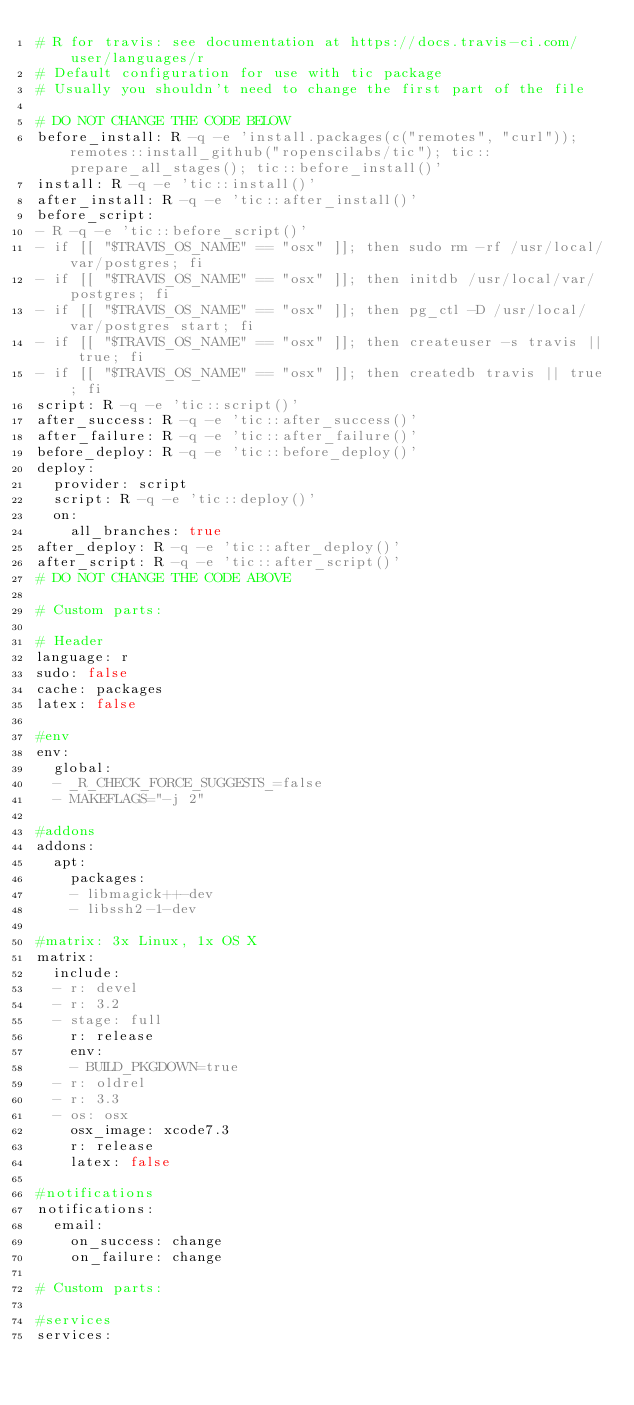Convert code to text. <code><loc_0><loc_0><loc_500><loc_500><_YAML_># R for travis: see documentation at https://docs.travis-ci.com/user/languages/r
# Default configuration for use with tic package
# Usually you shouldn't need to change the first part of the file

# DO NOT CHANGE THE CODE BELOW
before_install: R -q -e 'install.packages(c("remotes", "curl")); remotes::install_github("ropenscilabs/tic"); tic::prepare_all_stages(); tic::before_install()'
install: R -q -e 'tic::install()'
after_install: R -q -e 'tic::after_install()'
before_script:
- R -q -e 'tic::before_script()'
- if [[ "$TRAVIS_OS_NAME" == "osx" ]]; then sudo rm -rf /usr/local/var/postgres; fi
- if [[ "$TRAVIS_OS_NAME" == "osx" ]]; then initdb /usr/local/var/postgres; fi
- if [[ "$TRAVIS_OS_NAME" == "osx" ]]; then pg_ctl -D /usr/local/var/postgres start; fi
- if [[ "$TRAVIS_OS_NAME" == "osx" ]]; then createuser -s travis || true; fi
- if [[ "$TRAVIS_OS_NAME" == "osx" ]]; then createdb travis || true; fi
script: R -q -e 'tic::script()'
after_success: R -q -e 'tic::after_success()'
after_failure: R -q -e 'tic::after_failure()'
before_deploy: R -q -e 'tic::before_deploy()'
deploy:
  provider: script
  script: R -q -e 'tic::deploy()'
  on:
    all_branches: true
after_deploy: R -q -e 'tic::after_deploy()'
after_script: R -q -e 'tic::after_script()'
# DO NOT CHANGE THE CODE ABOVE

# Custom parts:

# Header
language: r
sudo: false
cache: packages
latex: false

#env
env:
  global:
  - _R_CHECK_FORCE_SUGGESTS_=false
  - MAKEFLAGS="-j 2"

#addons
addons:
  apt:
    packages:
    - libmagick++-dev
    - libssh2-1-dev

#matrix: 3x Linux, 1x OS X
matrix:
  include:
  - r: devel
  - r: 3.2
  - stage: full
    r: release
    env:
    - BUILD_PKGDOWN=true
  - r: oldrel
  - r: 3.3
  - os: osx
    osx_image: xcode7.3
    r: release
    latex: false

#notifications
notifications:
  email:
    on_success: change
    on_failure: change

# Custom parts:

#services
services:

</code> 